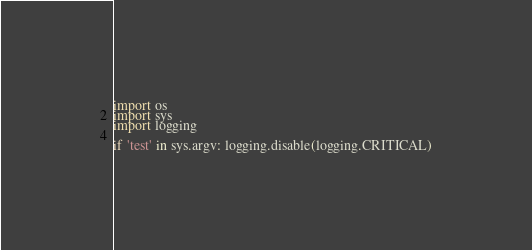<code> <loc_0><loc_0><loc_500><loc_500><_Python_>import os
import sys
import logging

if 'test' in sys.argv: logging.disable(logging.CRITICAL)</code> 